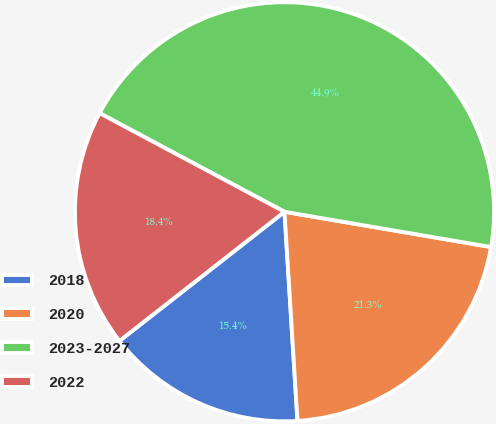<chart> <loc_0><loc_0><loc_500><loc_500><pie_chart><fcel>2018<fcel>2020<fcel>2023-2027<fcel>2022<nl><fcel>15.42%<fcel>21.32%<fcel>44.89%<fcel>18.37%<nl></chart> 